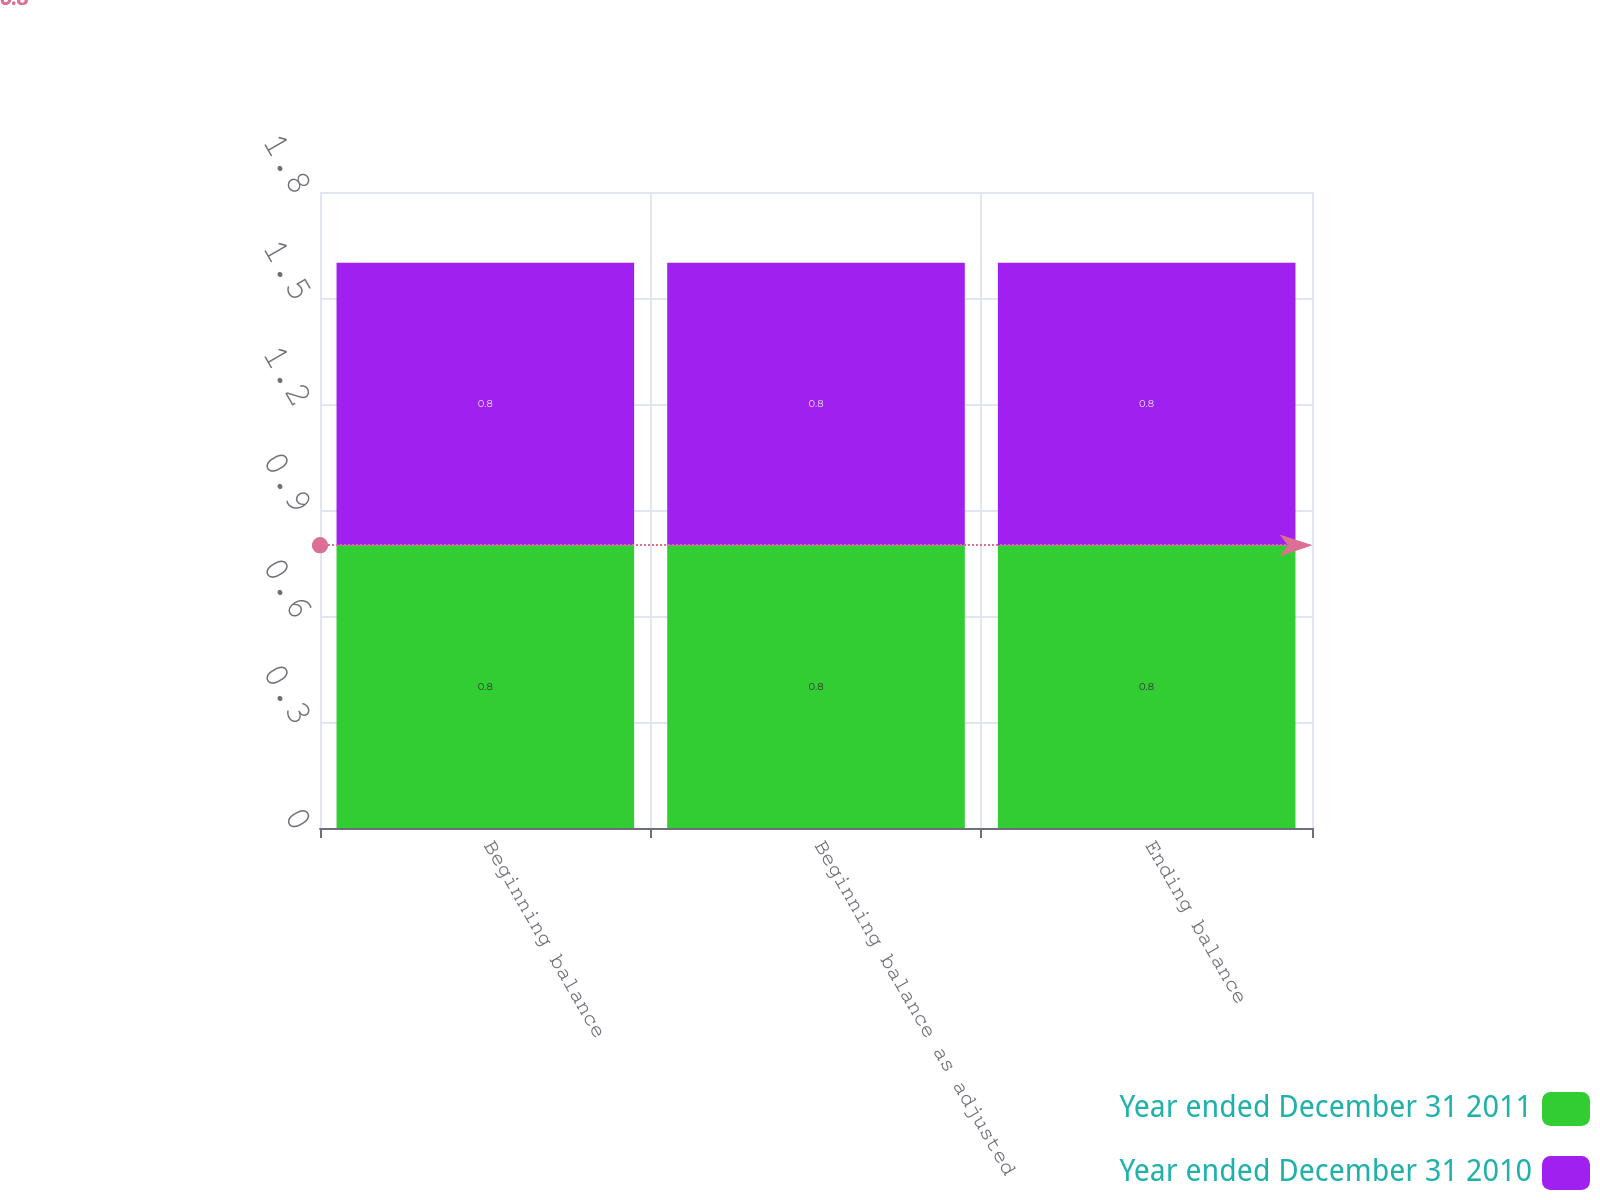<chart> <loc_0><loc_0><loc_500><loc_500><stacked_bar_chart><ecel><fcel>Beginning balance<fcel>Beginning balance as adjusted<fcel>Ending balance<nl><fcel>Year ended December 31 2011<fcel>0.8<fcel>0.8<fcel>0.8<nl><fcel>Year ended December 31 2010<fcel>0.8<fcel>0.8<fcel>0.8<nl></chart> 